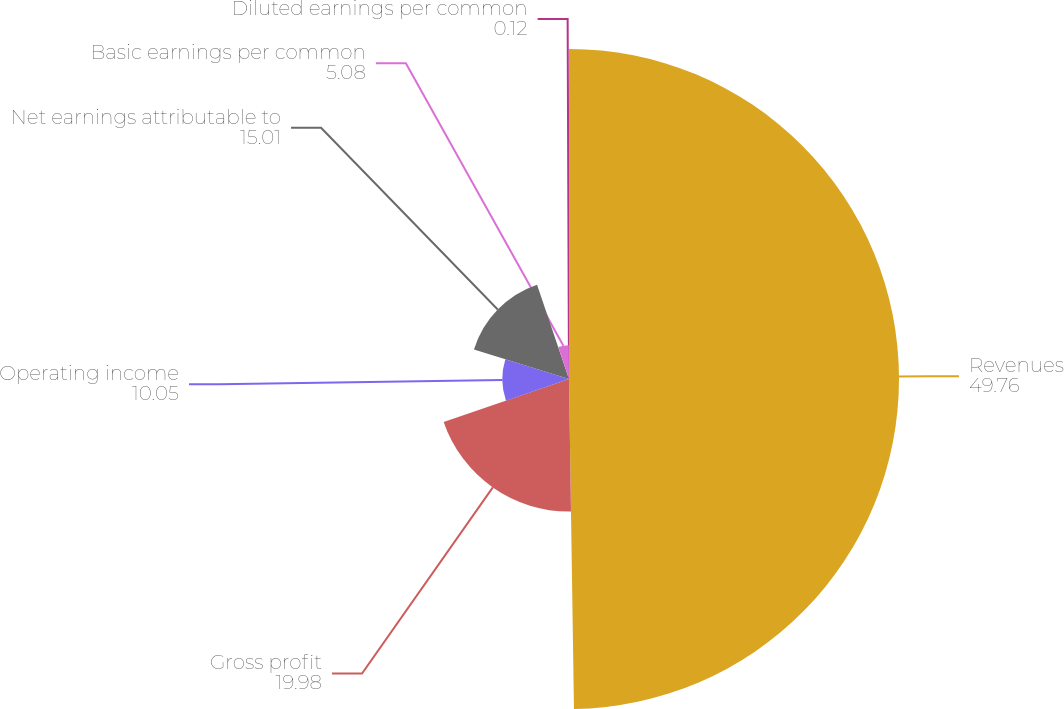<chart> <loc_0><loc_0><loc_500><loc_500><pie_chart><fcel>Revenues<fcel>Gross profit<fcel>Operating income<fcel>Net earnings attributable to<fcel>Basic earnings per common<fcel>Diluted earnings per common<nl><fcel>49.76%<fcel>19.98%<fcel>10.05%<fcel>15.01%<fcel>5.08%<fcel>0.12%<nl></chart> 